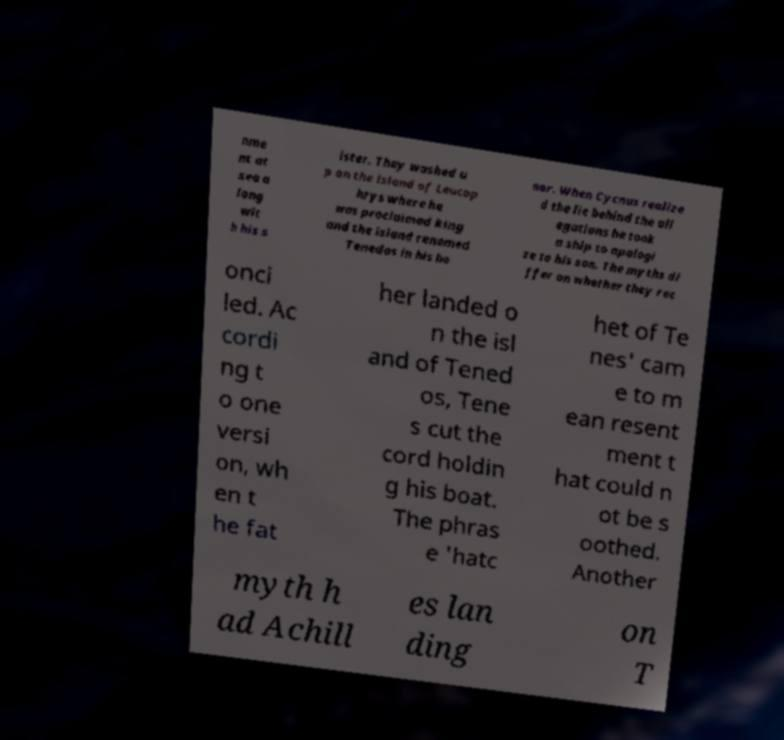Could you extract and type out the text from this image? nme nt at sea a long wit h his s ister. They washed u p on the island of Leucop hrys where he was proclaimed king and the island renamed Tenedos in his ho nor. When Cycnus realize d the lie behind the all egations he took a ship to apologi ze to his son. The myths di ffer on whether they rec onci led. Ac cordi ng t o one versi on, wh en t he fat her landed o n the isl and of Tened os, Tene s cut the cord holdin g his boat. The phras e 'hatc het of Te nes' cam e to m ean resent ment t hat could n ot be s oothed. Another myth h ad Achill es lan ding on T 